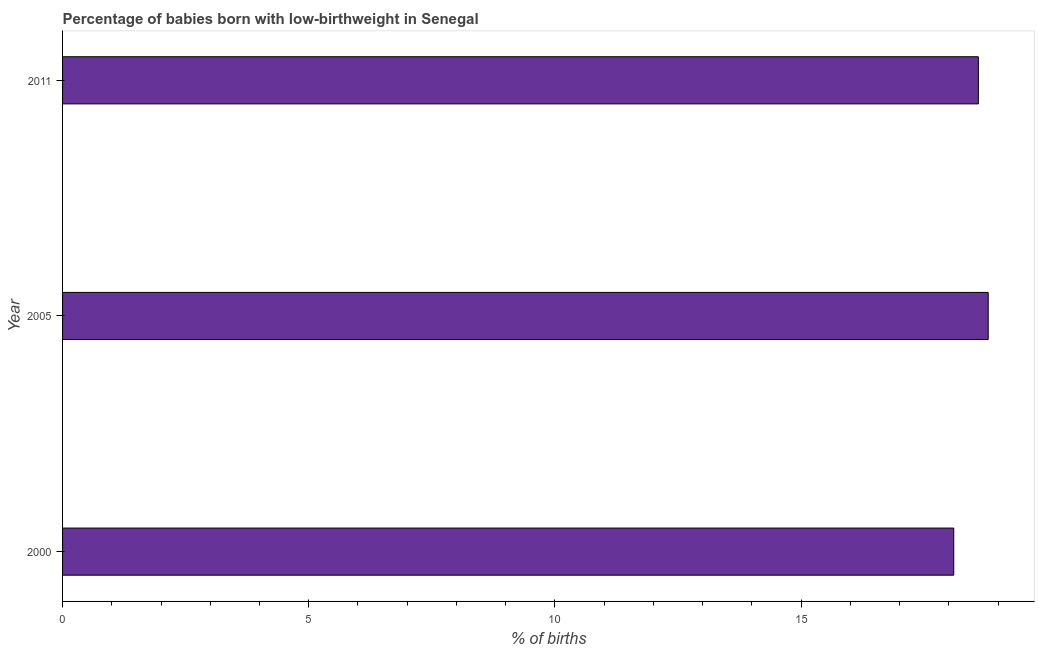Does the graph contain any zero values?
Make the answer very short. No. What is the title of the graph?
Keep it short and to the point. Percentage of babies born with low-birthweight in Senegal. What is the label or title of the X-axis?
Give a very brief answer. % of births. What is the label or title of the Y-axis?
Your answer should be very brief. Year. Across all years, what is the maximum percentage of babies who were born with low-birthweight?
Keep it short and to the point. 18.8. What is the sum of the percentage of babies who were born with low-birthweight?
Your response must be concise. 55.5. What is the average percentage of babies who were born with low-birthweight per year?
Offer a terse response. 18.5. In how many years, is the percentage of babies who were born with low-birthweight greater than 11 %?
Offer a terse response. 3. Do a majority of the years between 2000 and 2005 (inclusive) have percentage of babies who were born with low-birthweight greater than 18 %?
Ensure brevity in your answer.  Yes. What is the ratio of the percentage of babies who were born with low-birthweight in 2000 to that in 2011?
Ensure brevity in your answer.  0.97. Is the percentage of babies who were born with low-birthweight in 2000 less than that in 2005?
Give a very brief answer. Yes. Is the sum of the percentage of babies who were born with low-birthweight in 2005 and 2011 greater than the maximum percentage of babies who were born with low-birthweight across all years?
Offer a very short reply. Yes. Are all the bars in the graph horizontal?
Ensure brevity in your answer.  Yes. What is the % of births of 2005?
Provide a short and direct response. 18.8. What is the % of births in 2011?
Provide a short and direct response. 18.6. What is the difference between the % of births in 2000 and 2005?
Your answer should be very brief. -0.7. What is the difference between the % of births in 2000 and 2011?
Make the answer very short. -0.5. What is the difference between the % of births in 2005 and 2011?
Your answer should be very brief. 0.2. 